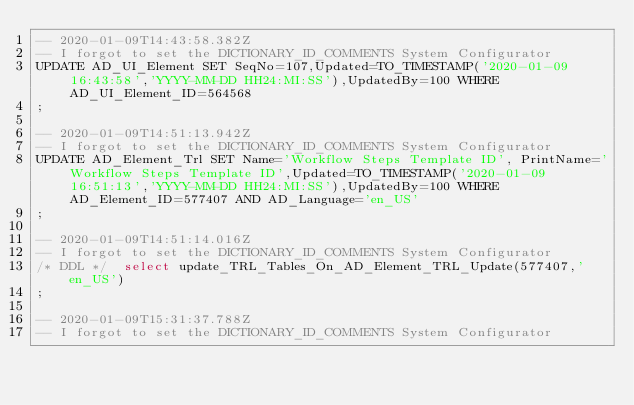Convert code to text. <code><loc_0><loc_0><loc_500><loc_500><_SQL_>-- 2020-01-09T14:43:58.382Z
-- I forgot to set the DICTIONARY_ID_COMMENTS System Configurator
UPDATE AD_UI_Element SET SeqNo=107,Updated=TO_TIMESTAMP('2020-01-09 16:43:58','YYYY-MM-DD HH24:MI:SS'),UpdatedBy=100 WHERE AD_UI_Element_ID=564568
;

-- 2020-01-09T14:51:13.942Z
-- I forgot to set the DICTIONARY_ID_COMMENTS System Configurator
UPDATE AD_Element_Trl SET Name='Workflow Steps Template ID', PrintName='Workflow Steps Template ID',Updated=TO_TIMESTAMP('2020-01-09 16:51:13','YYYY-MM-DD HH24:MI:SS'),UpdatedBy=100 WHERE AD_Element_ID=577407 AND AD_Language='en_US'
;

-- 2020-01-09T14:51:14.016Z
-- I forgot to set the DICTIONARY_ID_COMMENTS System Configurator
/* DDL */  select update_TRL_Tables_On_AD_Element_TRL_Update(577407,'en_US') 
;

-- 2020-01-09T15:31:37.788Z
-- I forgot to set the DICTIONARY_ID_COMMENTS System Configurator</code> 